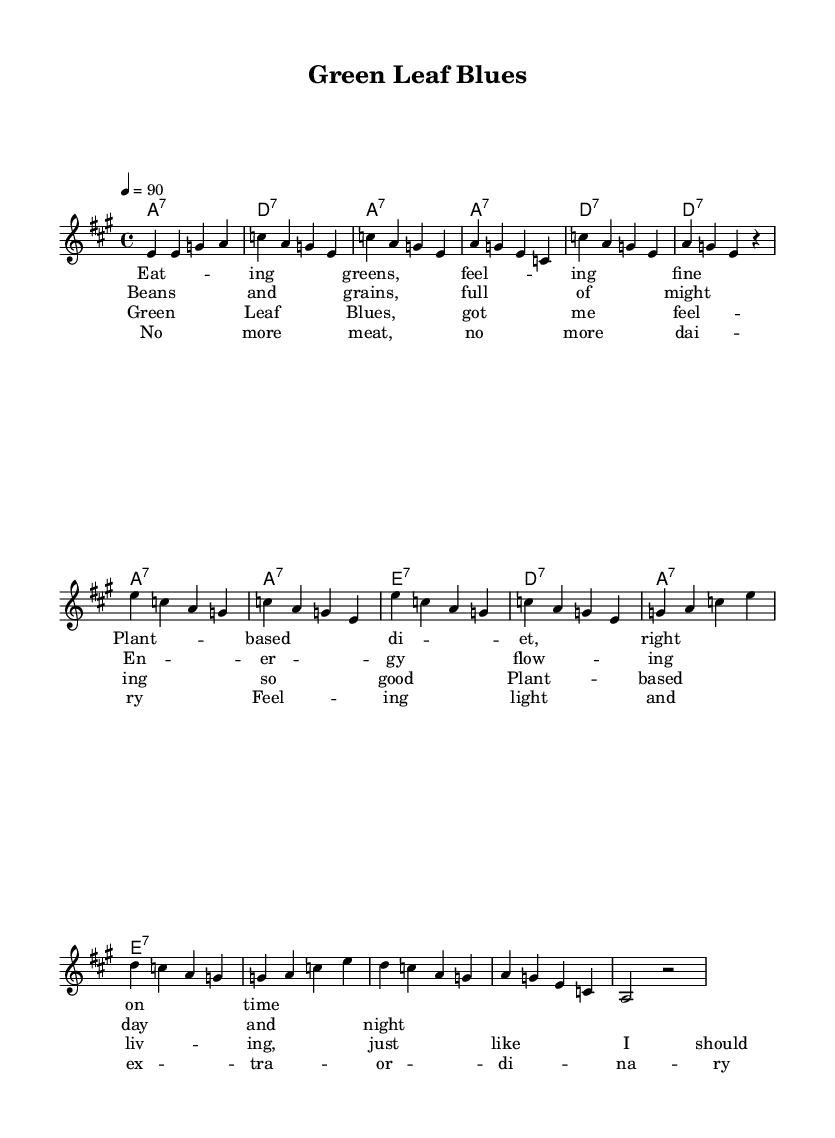What is the key signature of this music? The key signature is A major, which has three sharps (F#, C#, and G#). This can be identified by looking at the beginning of the staff where the sharps are located.
Answer: A major What is the time signature of this music? The time signature is 4/4, indicated at the beginning of the score. This means there are four beats in each measure and the quarter note receives one beat.
Answer: 4/4 What is the tempo marking for this piece? The tempo marking is 90 beats per minute, which specifies how fast the music should be played. This is found in the text indicating tempo at the beginning of the score.
Answer: 90 How many verses are in this song? The song contains two verses, as clearly separated by the lyrical sections labeled in the score, which can be counted in the lyrics provided.
Answer: Two Which section contains lyrics about plant-based living? The chorus contains lyrics specifically about plant-based living. This can be determined by looking for the section marked "Chorus" and identifying the content of the lyrics.
Answer: Chorus What type of harmony is used in this piece? The harmony consists of seventh chords, as indicated in the chord names written above the melody. Each chord is labeled with a "7" to indicate this type of harmony.
Answer: Seventh chords What is the overall mood expressed in the song? The overall mood of the song is positive and uplifting, expressing feelings of well-being associated with a plant-based diet. This can be inferred from the lyrics describing health and vitality.
Answer: Positive 